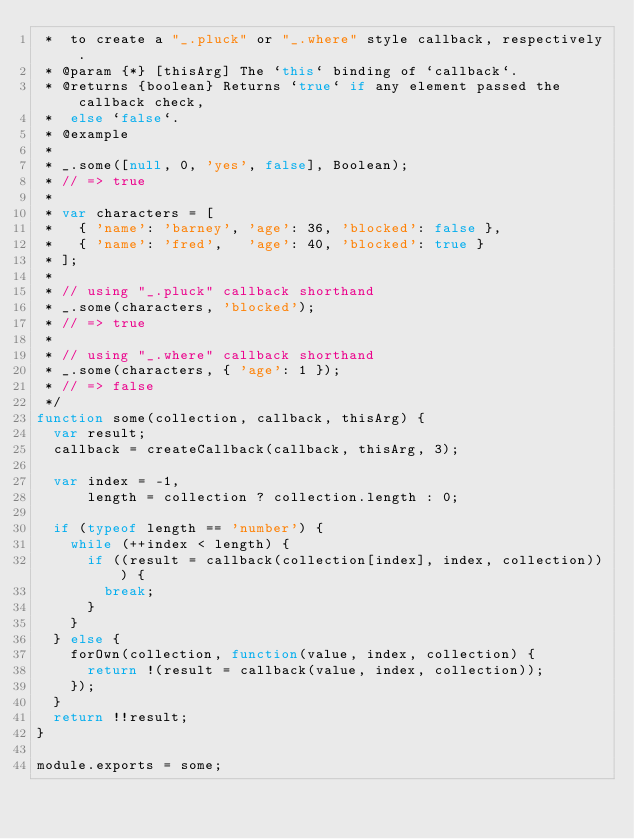<code> <loc_0><loc_0><loc_500><loc_500><_JavaScript_> *  to create a "_.pluck" or "_.where" style callback, respectively.
 * @param {*} [thisArg] The `this` binding of `callback`.
 * @returns {boolean} Returns `true` if any element passed the callback check,
 *  else `false`.
 * @example
 *
 * _.some([null, 0, 'yes', false], Boolean);
 * // => true
 *
 * var characters = [
 *   { 'name': 'barney', 'age': 36, 'blocked': false },
 *   { 'name': 'fred',   'age': 40, 'blocked': true }
 * ];
 *
 * // using "_.pluck" callback shorthand
 * _.some(characters, 'blocked');
 * // => true
 *
 * // using "_.where" callback shorthand
 * _.some(characters, { 'age': 1 });
 * // => false
 */
function some(collection, callback, thisArg) {
  var result;
  callback = createCallback(callback, thisArg, 3);

  var index = -1,
      length = collection ? collection.length : 0;

  if (typeof length == 'number') {
    while (++index < length) {
      if ((result = callback(collection[index], index, collection))) {
        break;
      }
    }
  } else {
    forOwn(collection, function(value, index, collection) {
      return !(result = callback(value, index, collection));
    });
  }
  return !!result;
}

module.exports = some;
</code> 